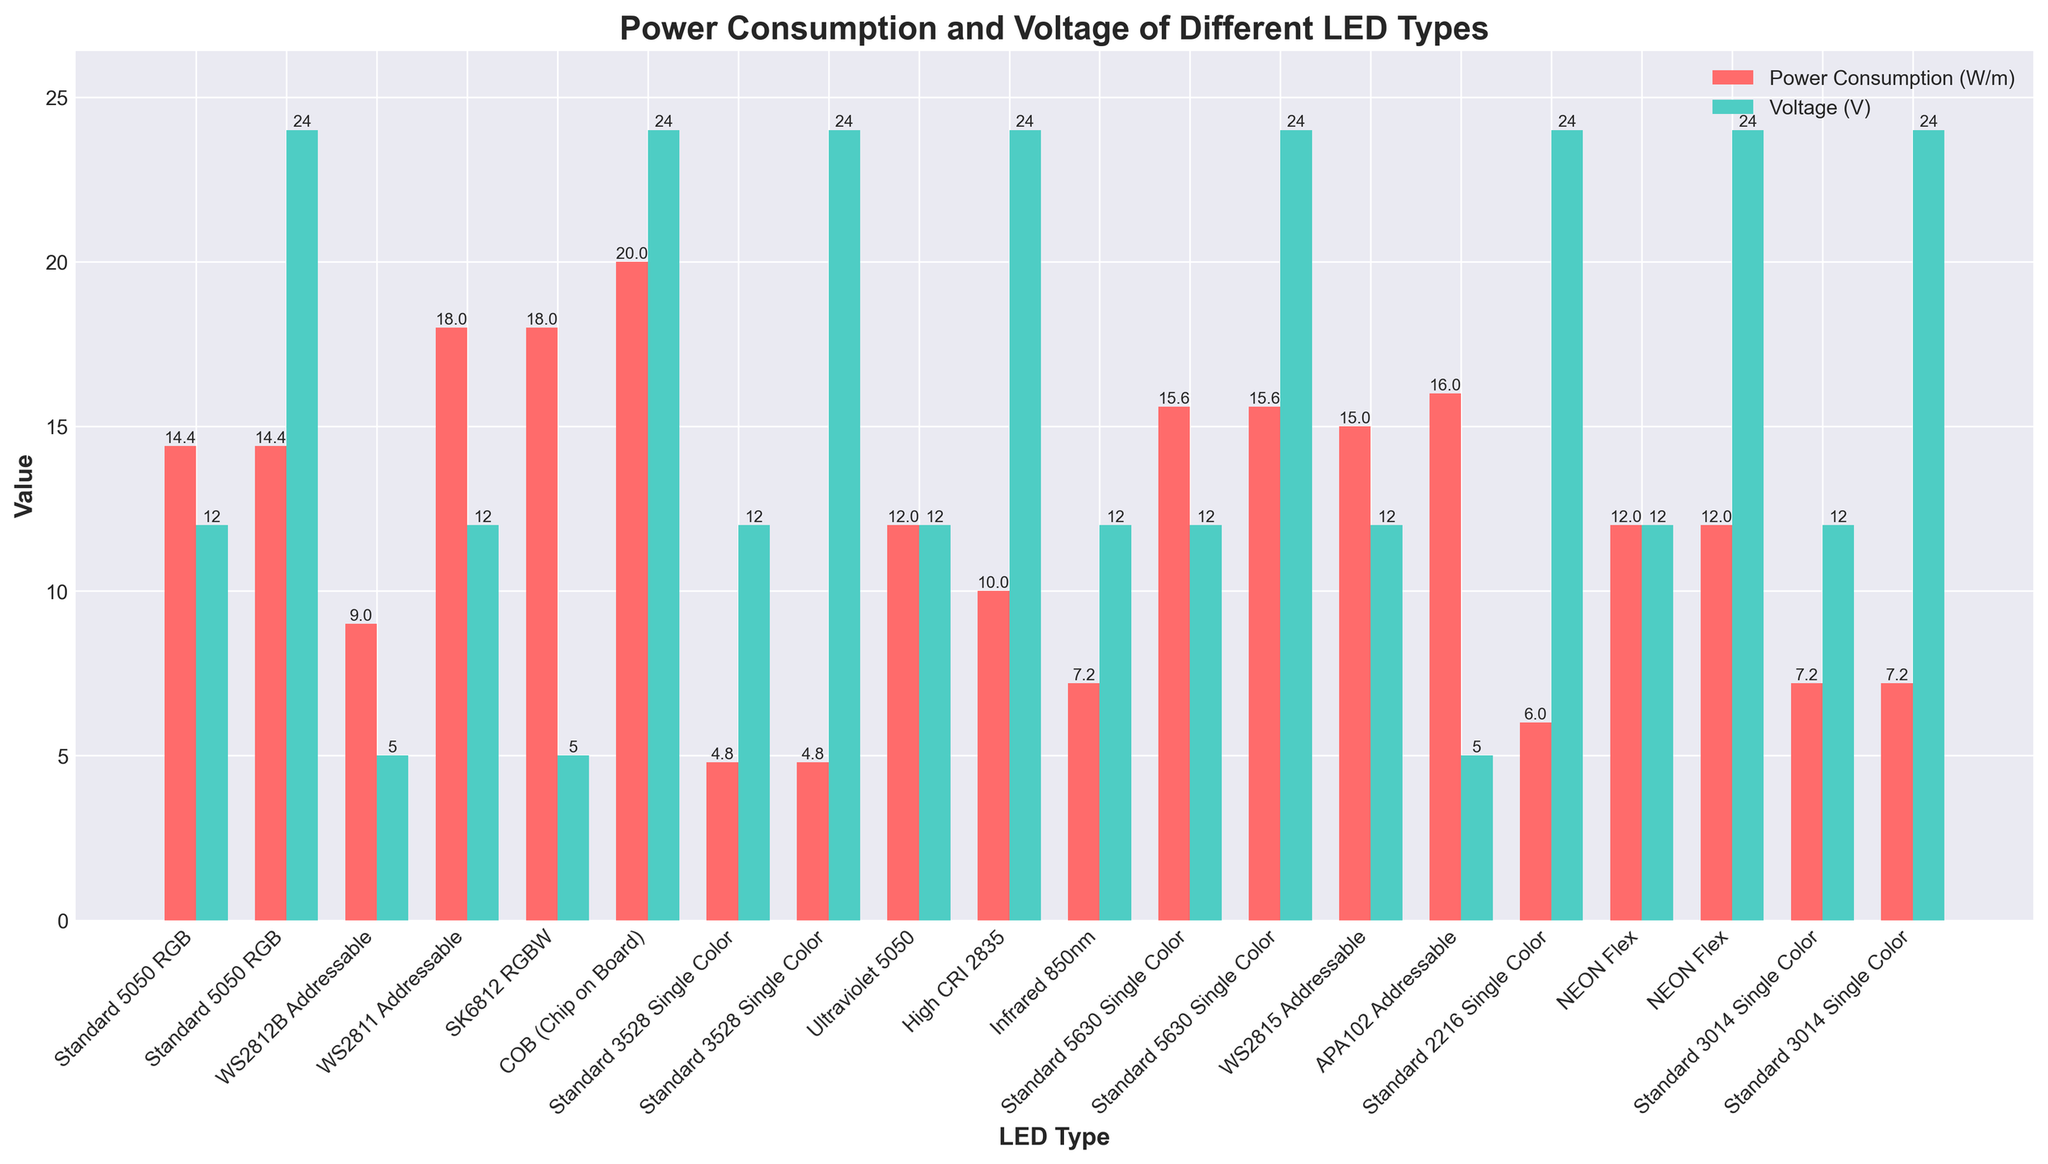Which LED type has the highest power consumption per meter? The bar representing the SK6812 RGBW LED type is the tallest among the power consumption bars, indicating that it has the highest power consumption.
Answer: SK6812 RGBW What is the voltage of the NEON Flex LED strips? There are two bars for NEON Flex and both are at the same height for voltage, showing it is 12V and 24V respectively.
Answer: 12V and 24V Which LED type has the same power consumption for both 12V and 24V variants? By comparing the heights of the bars, the Standard 5050 RGB, Standard 3528 Single Color, Standard 5630 Single Color, and NEON Flex have the same power consumption for both 12V and 24V.
Answer: Standard 5050 RGB, Standard 3528 Single Color, Standard 5630 Single Color, NEON Flex How much more power does the COB (Chip on Board) LED strip consume compared to the Standard 3528 Single Color? The power consumption bars for COB and Standard 3528 Single Color are at 20W/m and 4.8W/m, respectively. The difference is 20W/m - 4.8W/m = 15.2W/m.
Answer: 15.2W/m Among the addressable LED strips, which one has the lowest power consumption? By examining the power consumption bars for the WS2812B, WS2811, WS2815, and APA102 Addressable LED strips, the WS2812B has the lowest bar indicating 9W/m.
Answer: WS2812B What is the average power consumption of the single color LED strips? The single color LED strips are Standard 3528 (4.8W/m), High CRI 2835 (10W/m), Standard 5630 (15.6W/m), Standard 2216 (6W/m), and Standard 3014 (7.2W/m). Their average power consumption is (4.8 + 10 + 15.6 + 6 + 7.2) / 5 = 8.72W/m.
Answer: 8.72W/m Which LED type operates at the highest voltage? By comparing the voltage bars, all the highest voltage bars are at 24V, including Standard 5050 RGB, COB, Standard 3528 Single Color, High CRI 2835, Standard 5630 Single Color, Standard 2216 Single Color, NEON Flex, and Standard 3014 Single Color.
Answer: Multiple types at 24V What is the height difference between the power consumption bar and the voltage bar for the Standard 5050 RGB LED strip at 12V? The power consumption bar is at 14.4W/m and the voltage bar is at 12V. The height difference is 14.4 - 12 = 2.4.
Answer: 2.4 Compare the power consumption of the Infrared 850nm LED strip and the Standard 3014 Single Color LED strip. Which one consumes more power? By looking at the bars, the Infrared 850nm has a bar at 7.2W/m and the Standard 3014 Single Color has a bar also at 7.2W/m, indicating they consume the same power.
Answer: They consume the same power Which LED type has significantly different values for power consumption and voltage, and what are these values? The WS2811 Addressable has notably different values, where the power consumption is at 18W/m and voltage is at 12V, showing a significant difference between the two bars.
Answer: WS2811 Addressable, 18W/m (power consumption), 12V (voltage) 